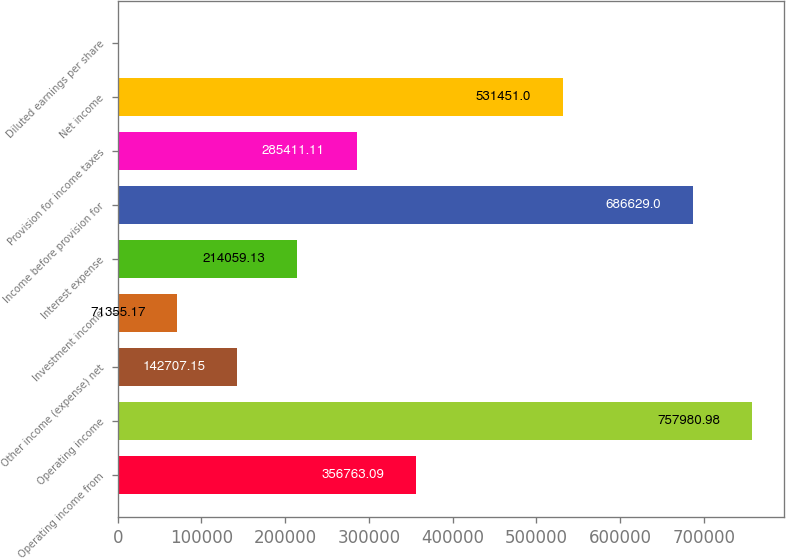Convert chart to OTSL. <chart><loc_0><loc_0><loc_500><loc_500><bar_chart><fcel>Operating income from<fcel>Operating income<fcel>Other income (expense) net<fcel>Investment income<fcel>Interest expense<fcel>Income before provision for<fcel>Provision for income taxes<fcel>Net income<fcel>Diluted earnings per share<nl><fcel>356763<fcel>757981<fcel>142707<fcel>71355.2<fcel>214059<fcel>686629<fcel>285411<fcel>531451<fcel>3.19<nl></chart> 